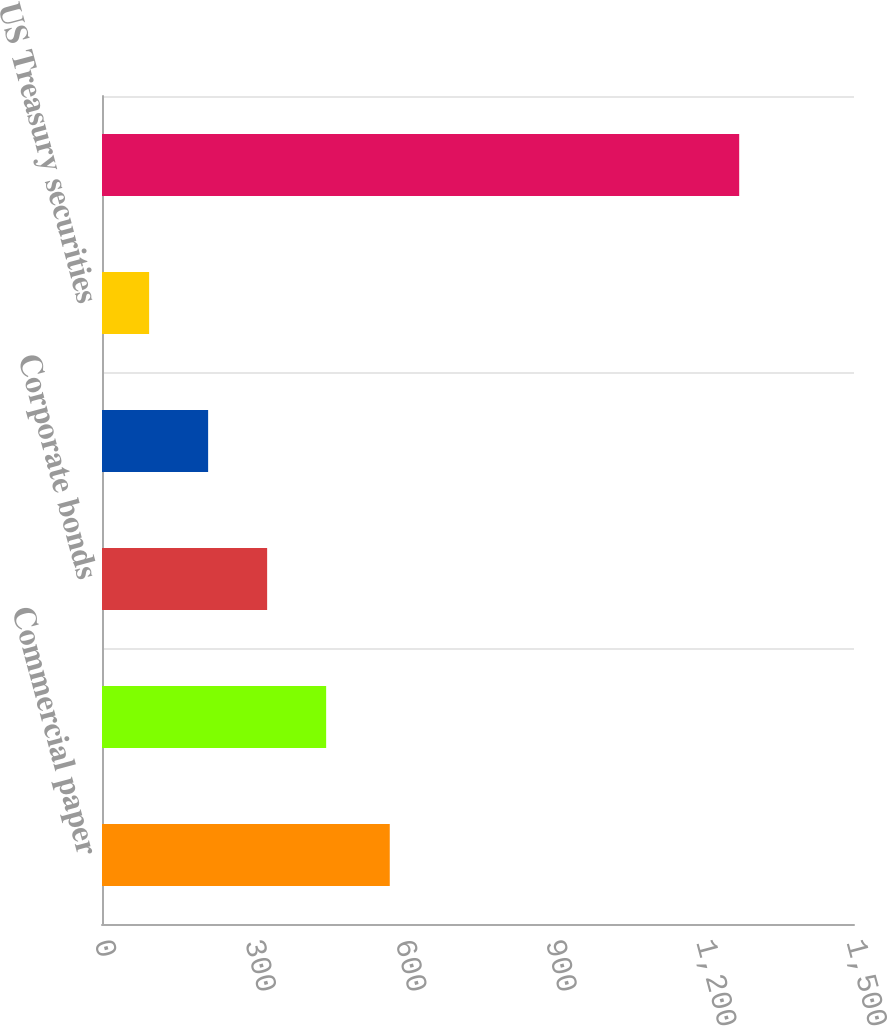<chart> <loc_0><loc_0><loc_500><loc_500><bar_chart><fcel>Commercial paper<fcel>US agency securities<fcel>Corporate bonds<fcel>Asset-backed securities<fcel>US Treasury securities<fcel>Total short-term investments<nl><fcel>574<fcel>447.1<fcel>329.4<fcel>211.7<fcel>94<fcel>1271<nl></chart> 